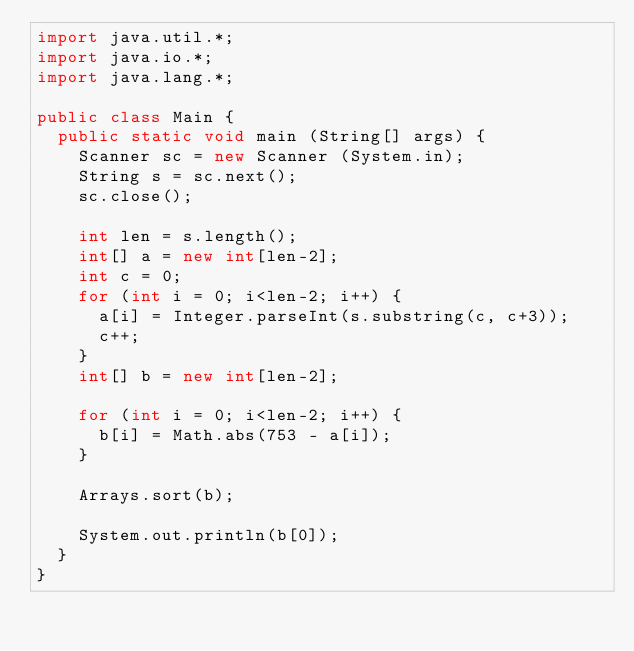Convert code to text. <code><loc_0><loc_0><loc_500><loc_500><_Java_>import java.util.*;
import java.io.*;
import java.lang.*;

public class Main {
	public static void main (String[] args) {
		Scanner sc = new Scanner (System.in);
		String s = sc.next();		
		sc.close();
		
		int len = s.length();
		int[] a = new int[len-2];
		int c = 0;
		for (int i = 0; i<len-2; i++) {
			a[i] = Integer.parseInt(s.substring(c, c+3));
			c++;
		}
		int[] b = new int[len-2];

		for (int i = 0; i<len-2; i++) {
			b[i] = Math.abs(753 - a[i]);
		}
		
		Arrays.sort(b);

		System.out.println(b[0]);
	}
}
</code> 